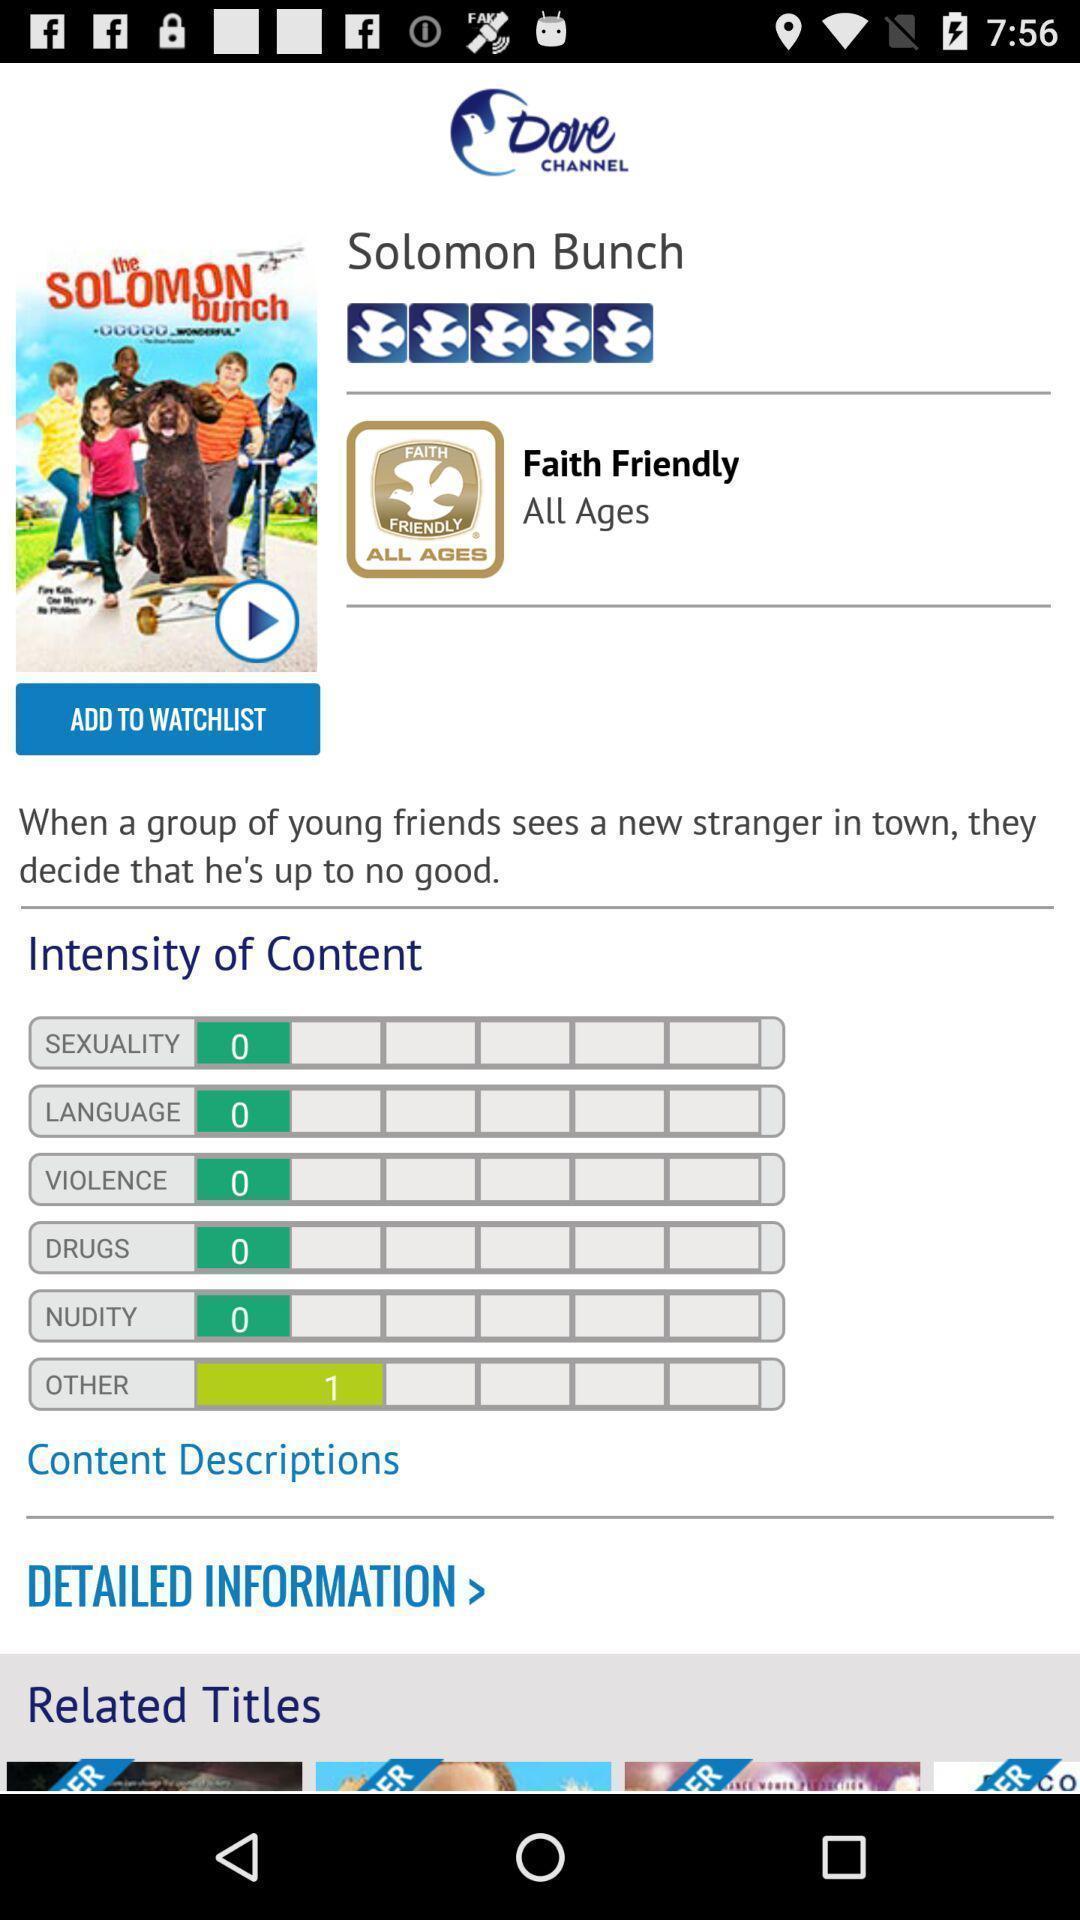Give me a narrative description of this picture. Screen displaying the page of movie details. 